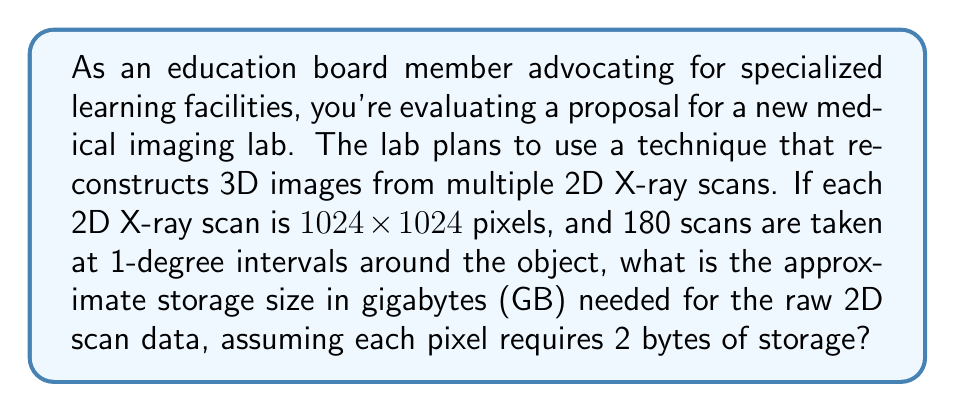Show me your answer to this math problem. Let's break this down step-by-step:

1) First, we need to calculate the total number of pixels in all the scans:
   - Each scan is $1024 \times 1024$ pixels = 1,048,576 pixels
   - There are 180 scans
   - Total pixels = $1,048,576 \times 180 = 188,743,680$ pixels

2) Each pixel requires 2 bytes of storage:
   - Total bytes = $188,743,680 \times 2 = 377,487,360$ bytes

3) Convert bytes to gigabytes:
   - 1 GB = $1,073,741,824$ bytes (2^30 bytes)
   - GB needed = $\frac{377,487,360}{1,073,741,824} \approx 0.3516$ GB

Therefore, the storage size needed for the raw 2D scan data is approximately 0.3516 GB.
Answer: 0.3516 GB 